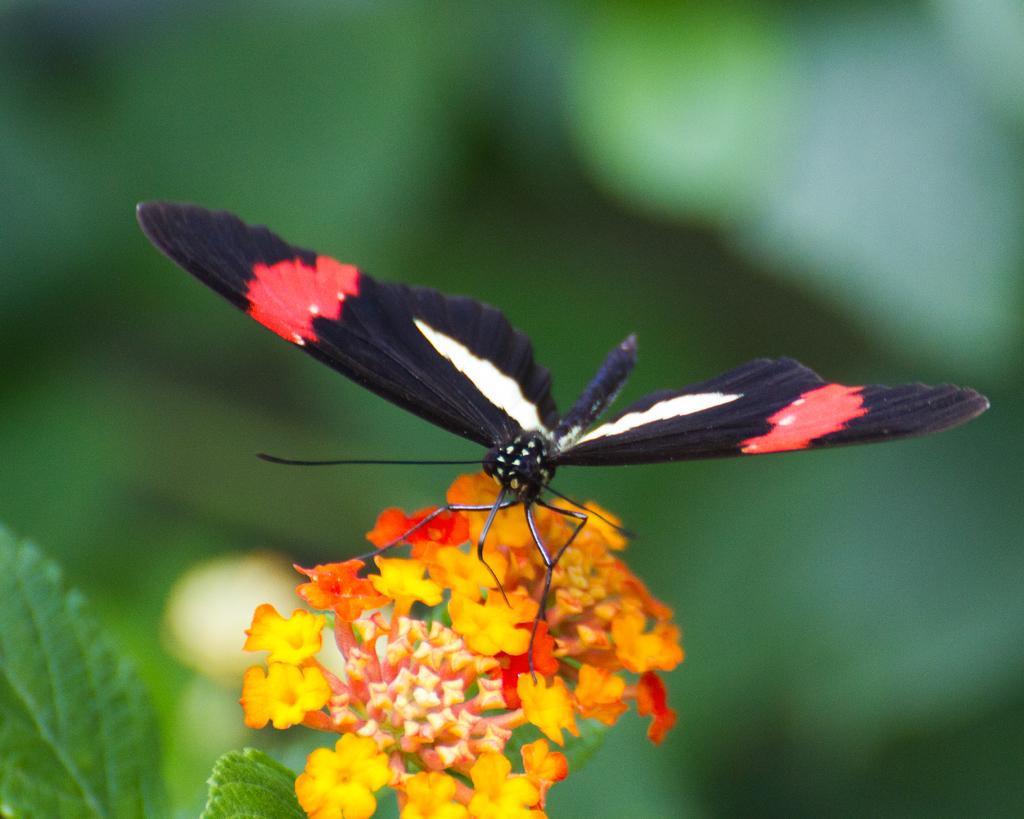Please provide a concise description of this image. In this picture we can observe a butterfly which is in black, red and white colors. This butterfly is on the flowers which are in yellow and red colors. We can observe leaves of a plant. The background is in green color which is completely blurred. 